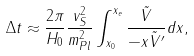Convert formula to latex. <formula><loc_0><loc_0><loc_500><loc_500>\Delta t \approx \frac { 2 \pi } { H _ { 0 } } \frac { v _ { S } ^ { 2 } } { m _ { P l } ^ { 2 } } \int _ { x _ { 0 } } ^ { x _ { e } } \frac { \tilde { V } } { - x \tilde { V } ^ { \prime } } d x ,</formula> 